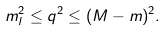<formula> <loc_0><loc_0><loc_500><loc_500>m _ { l } ^ { 2 } \leq q ^ { 2 } \leq ( M - m ) ^ { 2 } .</formula> 